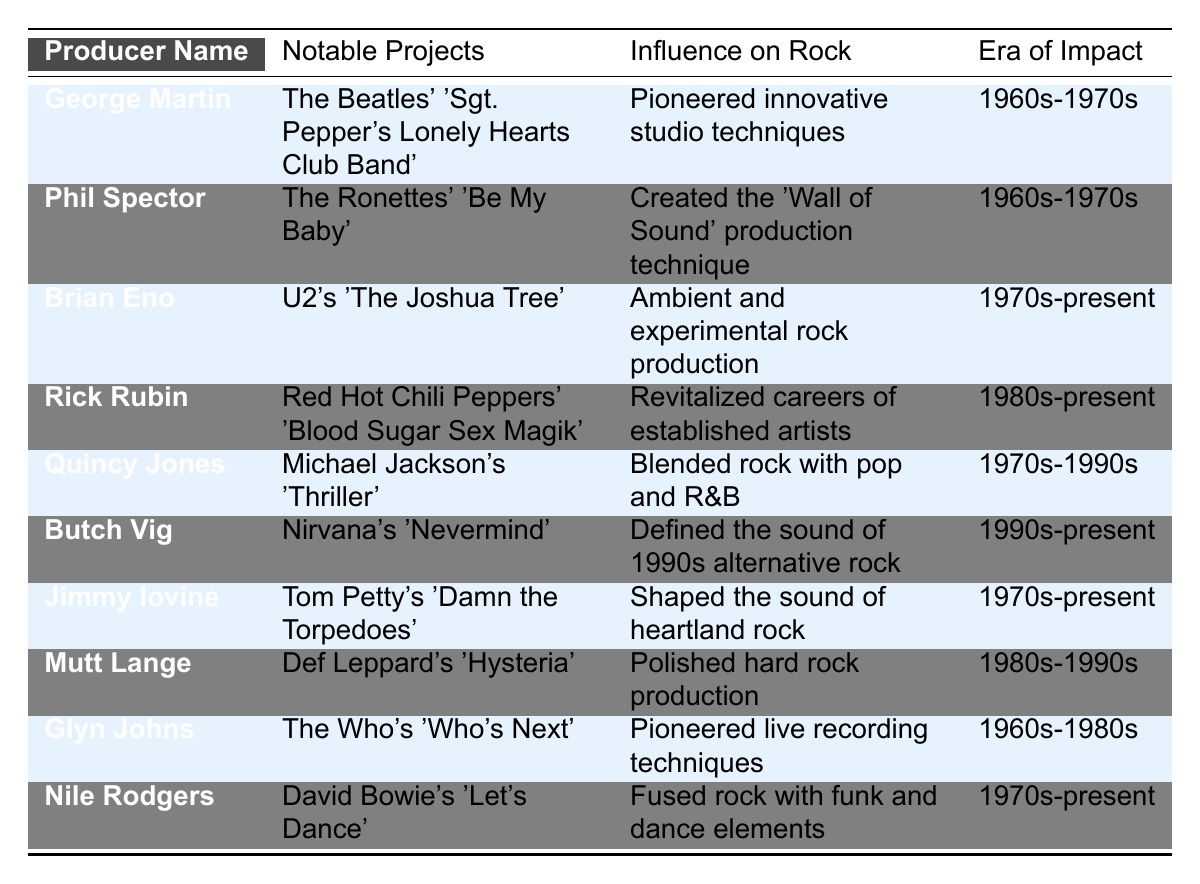What notable project is associated with George Martin? According to the table, George Martin is associated with "The Beatles' 'Sgt. Pepper's Lonely Hearts Club Band'" as his notable project.
Answer: The Beatles' 'Sgt. Pepper's Lonely Hearts Club Band' Which producer is known for pioneering innovative studio techniques? The table indicates that George Martin is known for pioneering innovative studio techniques in rock music.
Answer: George Martin What era of impact is recorded for Phil Spector? The table states that the era of impact for Phil Spector is the 1960s to 1970s.
Answer: 1960s-1970s Which project did Brian Eno work on that is noted in the table? Brian Eno is noted for his work on U2's 'The Joshua Tree' as per the table.
Answer: U2's 'The Joshua Tree' Is it true that Butch Vig defined the sound of 1990s alternative rock? Yes, the table confirms that Butch Vig is credited with defining the sound of 1990s alternative rock.
Answer: Yes How many music producers mentioned have an era of impact listed from the 1980s onward? The table lists 7 producers with "1980s-present" or "1970s-present" as their era of impact, which are Rick Rubin, Butch Vig, Jimmy Iovine, Mutt Lange, Brian Eno, Nile Rodgers, and Quincy Jones.
Answer: 5 Which producer worked on a notable project that fused rock with funk and dance elements? According to the table, Nile Rodgers is recognized for his work on a project that fused rock with funk and dance elements, specifically David Bowie's 'Let's Dance.'
Answer: Nile Rodgers Identify the producer who has had an impact during an era spanning from the 1960s to the 1980s. The table specifies Glyn Johns as the producer whose era of impact stretches from the 1960s to the 1980s.
Answer: Glyn Johns Which producer is associated with the "Wall of Sound" production technique? Phil Spector is the producer associated with creating the "Wall of Sound" production technique according to the table.
Answer: Phil Spector What is the primary influence of Rick Rubin on the rock genre? The table highlights that Rick Rubin revitalized the careers of established artists, marking his primary influence on the rock genre.
Answer: Revitalized careers of established artists 